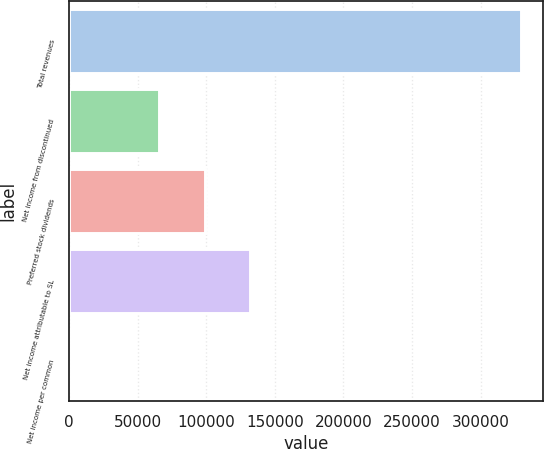<chart> <loc_0><loc_0><loc_500><loc_500><bar_chart><fcel>Total revenues<fcel>Net income from discontinued<fcel>Preferred stock dividends<fcel>Net income attributable to SL<fcel>Net income per common<nl><fcel>329222<fcel>65845.2<fcel>98767.3<fcel>131689<fcel>1.01<nl></chart> 